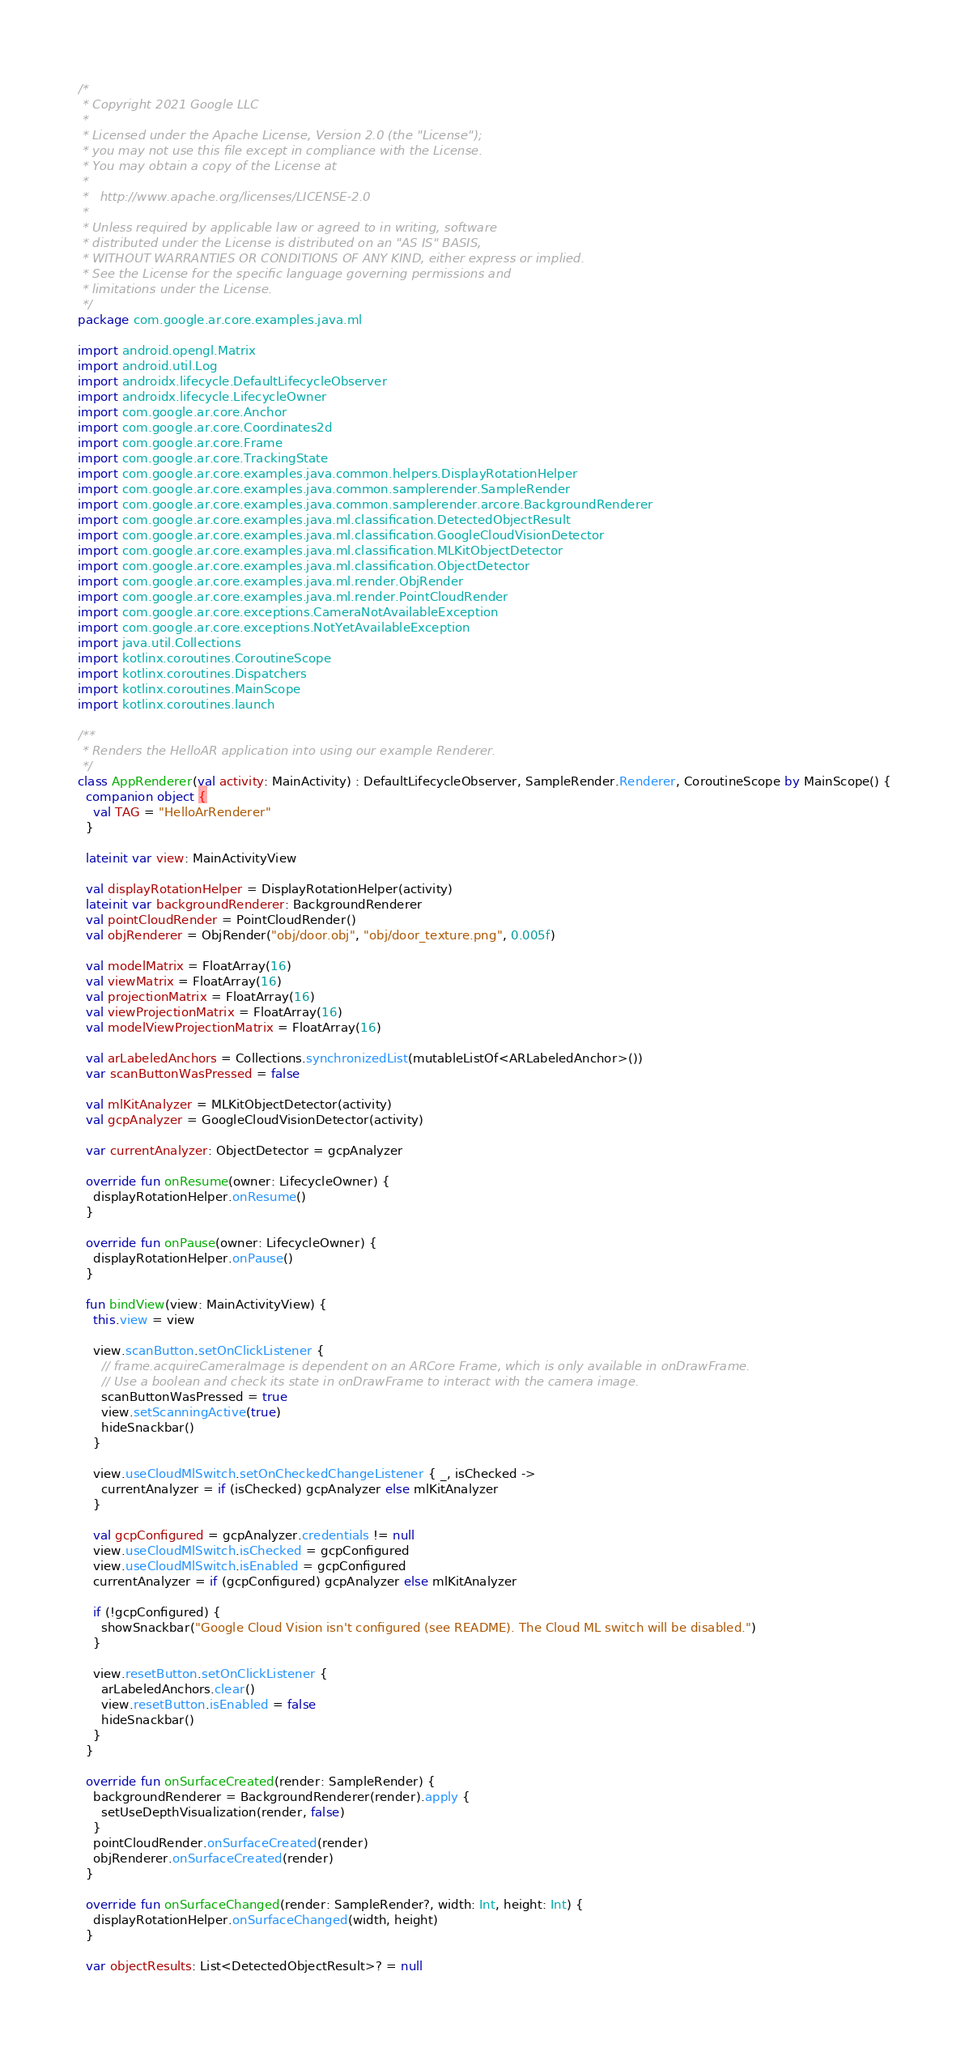<code> <loc_0><loc_0><loc_500><loc_500><_Kotlin_>/*
 * Copyright 2021 Google LLC
 *
 * Licensed under the Apache License, Version 2.0 (the "License");
 * you may not use this file except in compliance with the License.
 * You may obtain a copy of the License at
 *
 *   http://www.apache.org/licenses/LICENSE-2.0
 *
 * Unless required by applicable law or agreed to in writing, software
 * distributed under the License is distributed on an "AS IS" BASIS,
 * WITHOUT WARRANTIES OR CONDITIONS OF ANY KIND, either express or implied.
 * See the License for the specific language governing permissions and
 * limitations under the License.
 */
package com.google.ar.core.examples.java.ml

import android.opengl.Matrix
import android.util.Log
import androidx.lifecycle.DefaultLifecycleObserver
import androidx.lifecycle.LifecycleOwner
import com.google.ar.core.Anchor
import com.google.ar.core.Coordinates2d
import com.google.ar.core.Frame
import com.google.ar.core.TrackingState
import com.google.ar.core.examples.java.common.helpers.DisplayRotationHelper
import com.google.ar.core.examples.java.common.samplerender.SampleRender
import com.google.ar.core.examples.java.common.samplerender.arcore.BackgroundRenderer
import com.google.ar.core.examples.java.ml.classification.DetectedObjectResult
import com.google.ar.core.examples.java.ml.classification.GoogleCloudVisionDetector
import com.google.ar.core.examples.java.ml.classification.MLKitObjectDetector
import com.google.ar.core.examples.java.ml.classification.ObjectDetector
import com.google.ar.core.examples.java.ml.render.ObjRender
import com.google.ar.core.examples.java.ml.render.PointCloudRender
import com.google.ar.core.exceptions.CameraNotAvailableException
import com.google.ar.core.exceptions.NotYetAvailableException
import java.util.Collections
import kotlinx.coroutines.CoroutineScope
import kotlinx.coroutines.Dispatchers
import kotlinx.coroutines.MainScope
import kotlinx.coroutines.launch

/**
 * Renders the HelloAR application into using our example Renderer.
 */
class AppRenderer(val activity: MainActivity) : DefaultLifecycleObserver, SampleRender.Renderer, CoroutineScope by MainScope() {
  companion object {
    val TAG = "HelloArRenderer"
  }

  lateinit var view: MainActivityView

  val displayRotationHelper = DisplayRotationHelper(activity)
  lateinit var backgroundRenderer: BackgroundRenderer
  val pointCloudRender = PointCloudRender()
  val objRenderer = ObjRender("obj/door.obj", "obj/door_texture.png", 0.005f)

  val modelMatrix = FloatArray(16)
  val viewMatrix = FloatArray(16)
  val projectionMatrix = FloatArray(16)
  val viewProjectionMatrix = FloatArray(16)
  val modelViewProjectionMatrix = FloatArray(16)

  val arLabeledAnchors = Collections.synchronizedList(mutableListOf<ARLabeledAnchor>())
  var scanButtonWasPressed = false

  val mlKitAnalyzer = MLKitObjectDetector(activity)
  val gcpAnalyzer = GoogleCloudVisionDetector(activity)

  var currentAnalyzer: ObjectDetector = gcpAnalyzer

  override fun onResume(owner: LifecycleOwner) {
    displayRotationHelper.onResume()
  }

  override fun onPause(owner: LifecycleOwner) {
    displayRotationHelper.onPause()
  }

  fun bindView(view: MainActivityView) {
    this.view = view

    view.scanButton.setOnClickListener {
      // frame.acquireCameraImage is dependent on an ARCore Frame, which is only available in onDrawFrame.
      // Use a boolean and check its state in onDrawFrame to interact with the camera image.
      scanButtonWasPressed = true
      view.setScanningActive(true)
      hideSnackbar()
    }

    view.useCloudMlSwitch.setOnCheckedChangeListener { _, isChecked ->
      currentAnalyzer = if (isChecked) gcpAnalyzer else mlKitAnalyzer
    }

    val gcpConfigured = gcpAnalyzer.credentials != null
    view.useCloudMlSwitch.isChecked = gcpConfigured
    view.useCloudMlSwitch.isEnabled = gcpConfigured
    currentAnalyzer = if (gcpConfigured) gcpAnalyzer else mlKitAnalyzer

    if (!gcpConfigured) {
      showSnackbar("Google Cloud Vision isn't configured (see README). The Cloud ML switch will be disabled.")
    }

    view.resetButton.setOnClickListener {
      arLabeledAnchors.clear()
      view.resetButton.isEnabled = false
      hideSnackbar()
    }
  }

  override fun onSurfaceCreated(render: SampleRender) {
    backgroundRenderer = BackgroundRenderer(render).apply {
      setUseDepthVisualization(render, false)
    }
    pointCloudRender.onSurfaceCreated(render)
    objRenderer.onSurfaceCreated(render)
  }

  override fun onSurfaceChanged(render: SampleRender?, width: Int, height: Int) {
    displayRotationHelper.onSurfaceChanged(width, height)
  }

  var objectResults: List<DetectedObjectResult>? = null
</code> 